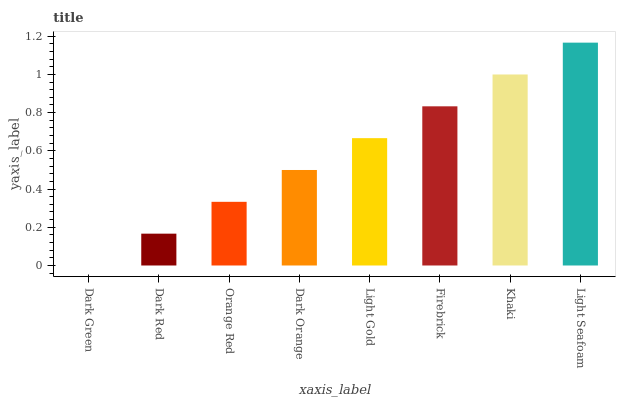Is Dark Red the minimum?
Answer yes or no. No. Is Dark Red the maximum?
Answer yes or no. No. Is Dark Red greater than Dark Green?
Answer yes or no. Yes. Is Dark Green less than Dark Red?
Answer yes or no. Yes. Is Dark Green greater than Dark Red?
Answer yes or no. No. Is Dark Red less than Dark Green?
Answer yes or no. No. Is Light Gold the high median?
Answer yes or no. Yes. Is Dark Orange the low median?
Answer yes or no. Yes. Is Dark Orange the high median?
Answer yes or no. No. Is Khaki the low median?
Answer yes or no. No. 